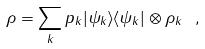<formula> <loc_0><loc_0><loc_500><loc_500>\rho = \sum _ { k } p _ { k } | \psi _ { k } \rangle \langle \psi _ { k } | \otimes \rho _ { k } \ ,</formula> 